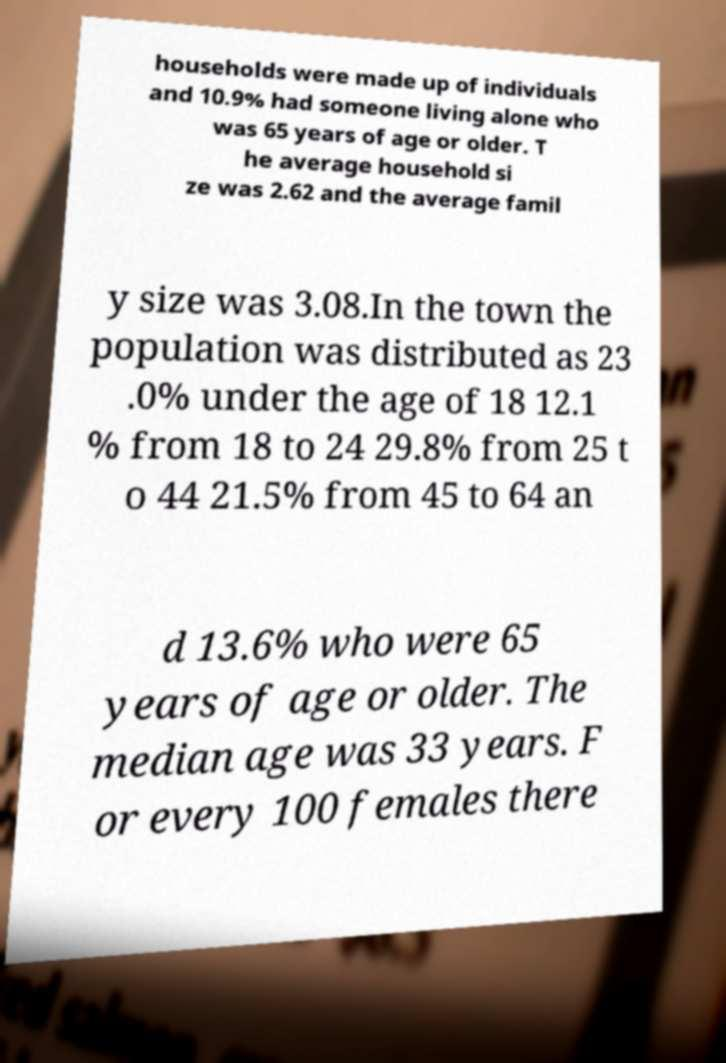I need the written content from this picture converted into text. Can you do that? households were made up of individuals and 10.9% had someone living alone who was 65 years of age or older. T he average household si ze was 2.62 and the average famil y size was 3.08.In the town the population was distributed as 23 .0% under the age of 18 12.1 % from 18 to 24 29.8% from 25 t o 44 21.5% from 45 to 64 an d 13.6% who were 65 years of age or older. The median age was 33 years. F or every 100 females there 